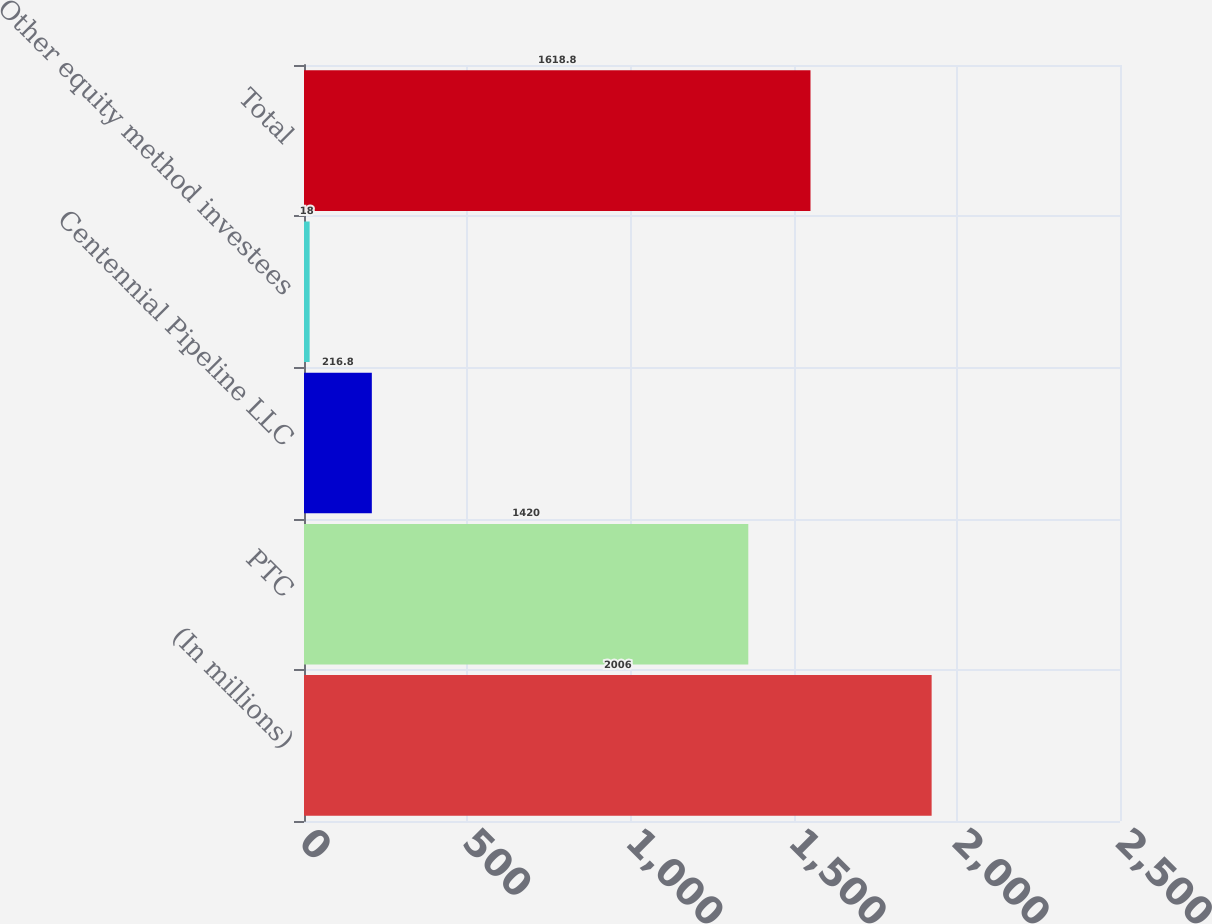Convert chart. <chart><loc_0><loc_0><loc_500><loc_500><bar_chart><fcel>(In millions)<fcel>PTC<fcel>Centennial Pipeline LLC<fcel>Other equity method investees<fcel>Total<nl><fcel>2006<fcel>1420<fcel>216.8<fcel>18<fcel>1618.8<nl></chart> 